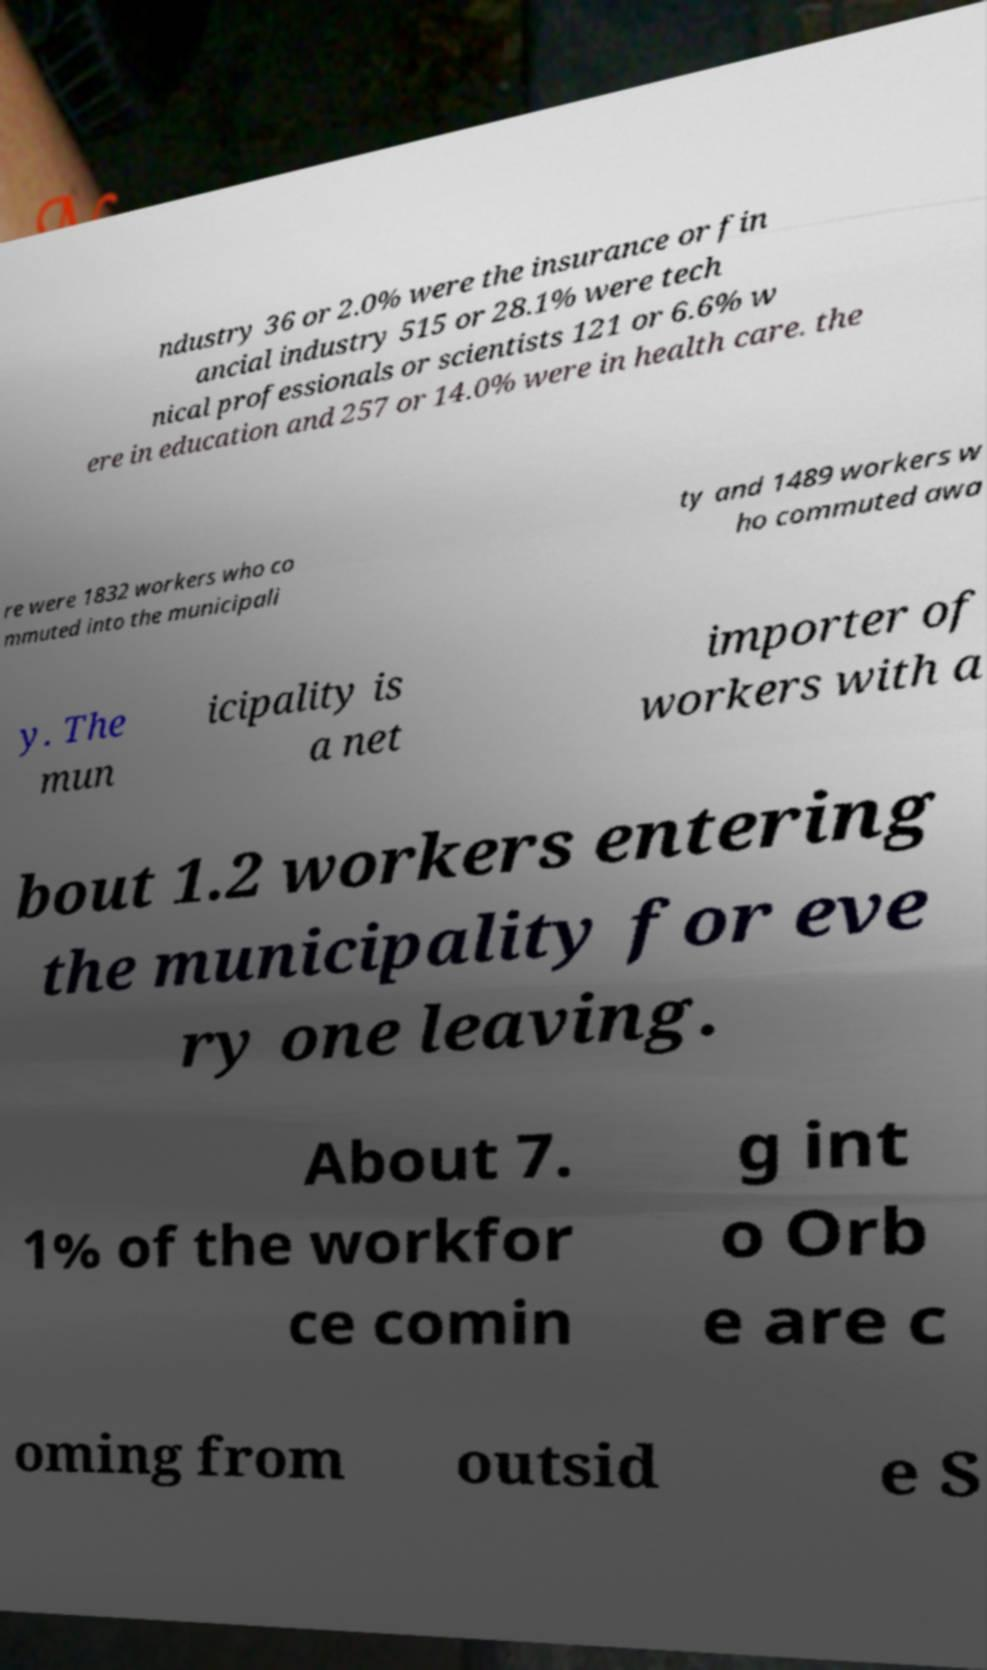For documentation purposes, I need the text within this image transcribed. Could you provide that? ndustry 36 or 2.0% were the insurance or fin ancial industry 515 or 28.1% were tech nical professionals or scientists 121 or 6.6% w ere in education and 257 or 14.0% were in health care. the re were 1832 workers who co mmuted into the municipali ty and 1489 workers w ho commuted awa y. The mun icipality is a net importer of workers with a bout 1.2 workers entering the municipality for eve ry one leaving. About 7. 1% of the workfor ce comin g int o Orb e are c oming from outsid e S 